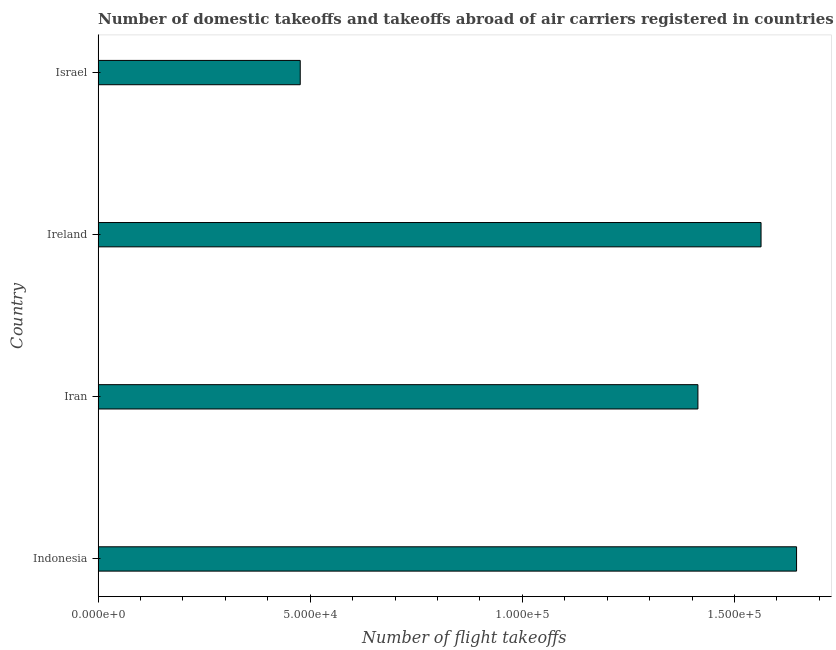Does the graph contain any zero values?
Offer a very short reply. No. What is the title of the graph?
Ensure brevity in your answer.  Number of domestic takeoffs and takeoffs abroad of air carriers registered in countries. What is the label or title of the X-axis?
Provide a succinct answer. Number of flight takeoffs. What is the label or title of the Y-axis?
Offer a very short reply. Country. What is the number of flight takeoffs in Israel?
Provide a short and direct response. 4.76e+04. Across all countries, what is the maximum number of flight takeoffs?
Your response must be concise. 1.65e+05. Across all countries, what is the minimum number of flight takeoffs?
Offer a terse response. 4.76e+04. In which country was the number of flight takeoffs minimum?
Your response must be concise. Israel. What is the sum of the number of flight takeoffs?
Make the answer very short. 5.10e+05. What is the difference between the number of flight takeoffs in Indonesia and Israel?
Ensure brevity in your answer.  1.17e+05. What is the average number of flight takeoffs per country?
Offer a terse response. 1.27e+05. What is the median number of flight takeoffs?
Provide a succinct answer. 1.49e+05. In how many countries, is the number of flight takeoffs greater than 140000 ?
Ensure brevity in your answer.  3. What is the ratio of the number of flight takeoffs in Indonesia to that in Iran?
Give a very brief answer. 1.16. Is the difference between the number of flight takeoffs in Iran and Israel greater than the difference between any two countries?
Your response must be concise. No. What is the difference between the highest and the second highest number of flight takeoffs?
Your response must be concise. 8374. Is the sum of the number of flight takeoffs in Iran and Ireland greater than the maximum number of flight takeoffs across all countries?
Offer a very short reply. Yes. What is the difference between the highest and the lowest number of flight takeoffs?
Offer a very short reply. 1.17e+05. In how many countries, is the number of flight takeoffs greater than the average number of flight takeoffs taken over all countries?
Make the answer very short. 3. How many bars are there?
Give a very brief answer. 4. Are the values on the major ticks of X-axis written in scientific E-notation?
Your response must be concise. Yes. What is the Number of flight takeoffs in Indonesia?
Ensure brevity in your answer.  1.65e+05. What is the Number of flight takeoffs of Iran?
Provide a short and direct response. 1.41e+05. What is the Number of flight takeoffs of Ireland?
Offer a very short reply. 1.56e+05. What is the Number of flight takeoffs in Israel?
Your answer should be compact. 4.76e+04. What is the difference between the Number of flight takeoffs in Indonesia and Iran?
Give a very brief answer. 2.33e+04. What is the difference between the Number of flight takeoffs in Indonesia and Ireland?
Provide a succinct answer. 8374. What is the difference between the Number of flight takeoffs in Indonesia and Israel?
Keep it short and to the point. 1.17e+05. What is the difference between the Number of flight takeoffs in Iran and Ireland?
Your response must be concise. -1.49e+04. What is the difference between the Number of flight takeoffs in Iran and Israel?
Offer a terse response. 9.37e+04. What is the difference between the Number of flight takeoffs in Ireland and Israel?
Make the answer very short. 1.09e+05. What is the ratio of the Number of flight takeoffs in Indonesia to that in Iran?
Offer a terse response. 1.16. What is the ratio of the Number of flight takeoffs in Indonesia to that in Ireland?
Your answer should be very brief. 1.05. What is the ratio of the Number of flight takeoffs in Indonesia to that in Israel?
Your answer should be very brief. 3.46. What is the ratio of the Number of flight takeoffs in Iran to that in Ireland?
Ensure brevity in your answer.  0.91. What is the ratio of the Number of flight takeoffs in Iran to that in Israel?
Keep it short and to the point. 2.97. What is the ratio of the Number of flight takeoffs in Ireland to that in Israel?
Keep it short and to the point. 3.28. 